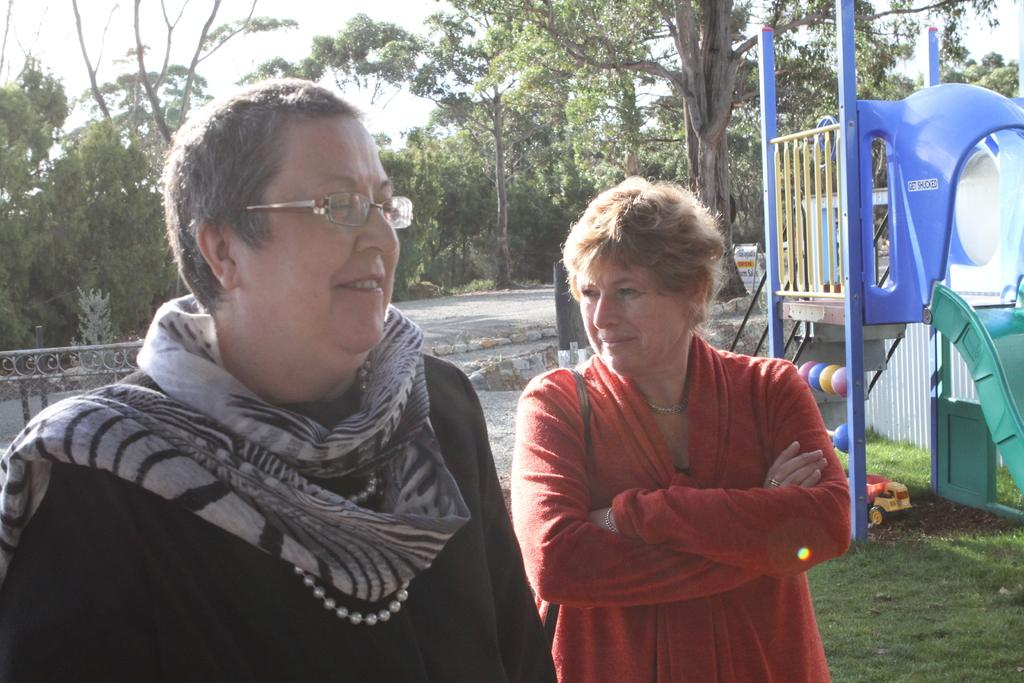How many people are in the image? There are two people in the image. What can be seen in the image besides the people? There is a slide, toys, a board with text, a fence, a road, grass, trees, and the sky visible in the image. What type of punishment is being administered to the people in the image? There is no punishment being administered to the people in the image; they are simply present in the scene. Can you describe the fog in the image? There is no fog present in the image; the sky is visible and appears clear. 